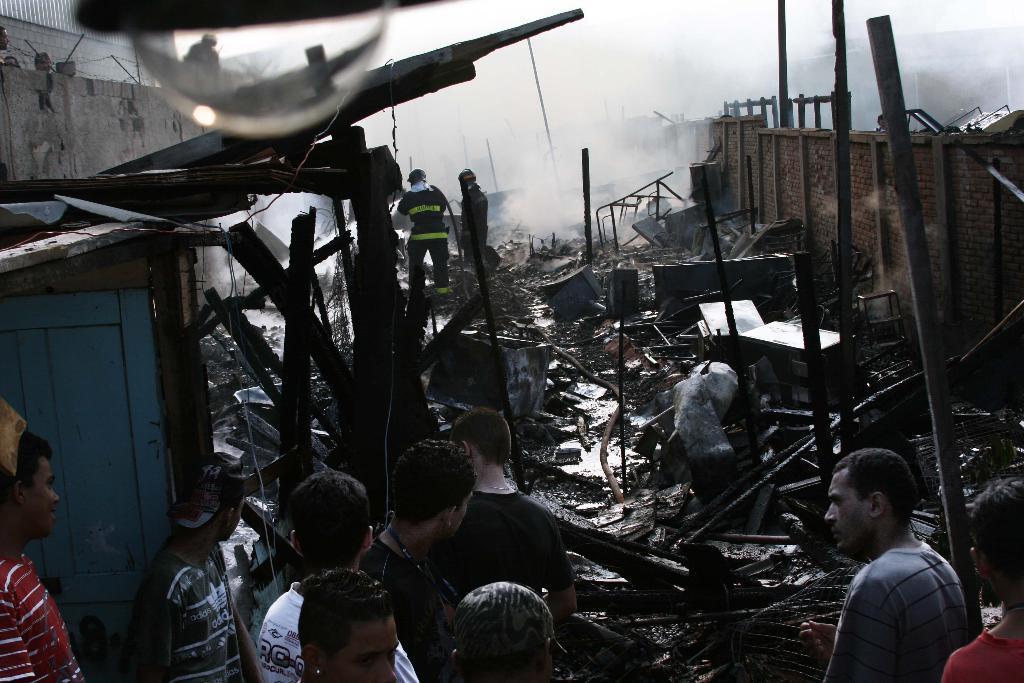In one or two sentences, can you explain what this image depicts? In the foreground of this picture, there are persons standing and in the background, we can see the broken tables, and the damaged walls and the smoke. On the top, there is a bulb. 